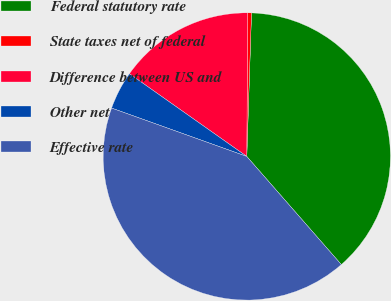Convert chart. <chart><loc_0><loc_0><loc_500><loc_500><pie_chart><fcel>Federal statutory rate<fcel>State taxes net of federal<fcel>Difference between US and<fcel>Other net<fcel>Effective rate<nl><fcel>38.04%<fcel>0.43%<fcel>15.32%<fcel>4.3%<fcel>41.9%<nl></chart> 